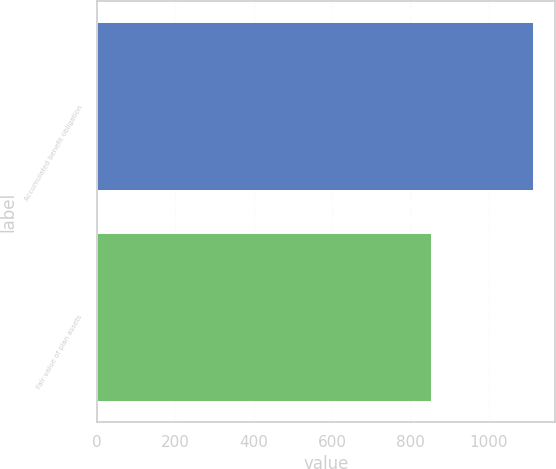Convert chart. <chart><loc_0><loc_0><loc_500><loc_500><bar_chart><fcel>Accumulated benefit obligation<fcel>Fair value of plan assets<nl><fcel>1113<fcel>851<nl></chart> 